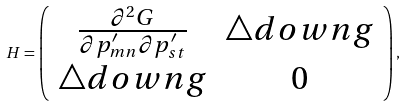Convert formula to latex. <formula><loc_0><loc_0><loc_500><loc_500>H = \left ( \begin{array} { c c } \frac { \partial ^ { 2 } G } { \partial p ^ { \prime } _ { m n } \partial p ^ { \prime } _ { s t } } & \triangle d o w n g \\ \triangle d o w n g & 0 \end{array} \right ) ,</formula> 